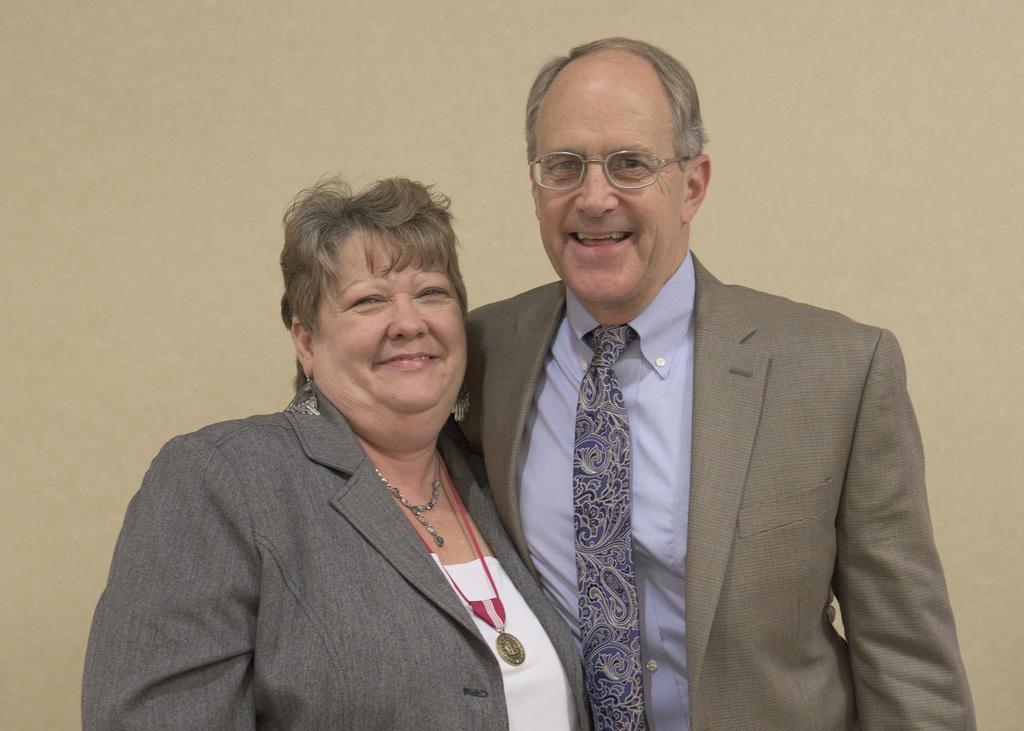Describe this image in one or two sentences. There is a man and a woman in the center of the image, it seems like a wall in the background area. 